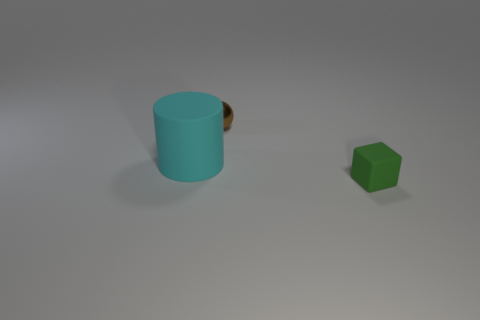Is there any other thing that is the same size as the cyan rubber object?
Keep it short and to the point. No. How many other things are the same shape as the small green thing?
Ensure brevity in your answer.  0. There is a matte thing that is in front of the large cyan matte cylinder; does it have the same size as the matte thing that is behind the green matte thing?
Your answer should be compact. No. Is there any other thing that has the same material as the tiny brown thing?
Ensure brevity in your answer.  No. What is the material of the tiny thing in front of the rubber thing left of the object that is in front of the cyan rubber thing?
Give a very brief answer. Rubber. What size is the other thing that is the same material as the small green object?
Provide a succinct answer. Large. What number of blue things are either tiny metallic objects or rubber blocks?
Offer a very short reply. 0. What number of tiny brown objects are in front of the small object left of the green cube?
Offer a terse response. 0. Is the number of matte cylinders behind the green thing greater than the number of large cyan things behind the brown object?
Your answer should be compact. Yes. What material is the brown object?
Offer a terse response. Metal. 